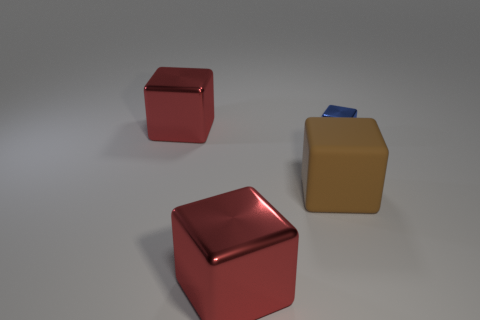Does the matte object have the same size as the blue metal block?
Your answer should be compact. No. Is the number of big red objects in front of the small blue object less than the number of metal cubes that are in front of the brown cube?
Your answer should be compact. No. Are there any other things that are the same size as the rubber object?
Your answer should be very brief. Yes. What is the size of the blue thing?
Ensure brevity in your answer.  Small. How many big objects are either blue things or brown metal things?
Your answer should be compact. 0. There is a brown matte thing; does it have the same size as the shiny thing behind the tiny object?
Ensure brevity in your answer.  Yes. Is there anything else that has the same shape as the tiny metal object?
Make the answer very short. Yes. How many small blue metal blocks are there?
Your answer should be compact. 1. What number of red objects are either matte cubes or tiny cubes?
Your answer should be very brief. 0. Is the material of the big brown object left of the tiny shiny object the same as the blue cube?
Make the answer very short. No. 